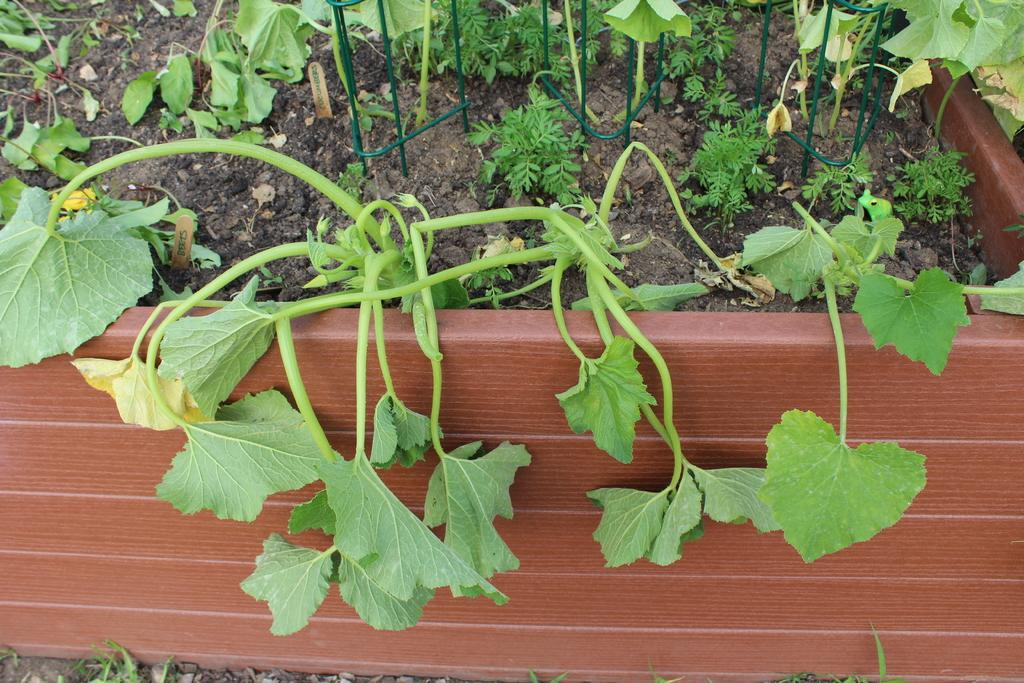What types of living organisms are present in the image? The image contains different types of plants. How are the plants arranged in the image? There are plants planted in a pot. What is the color of the pot? The pot is red in color. Can you tell me how many geese are sitting on the red pot in the image? There are no geese present in the image; it only contains different types of plants planted in a red pot. 